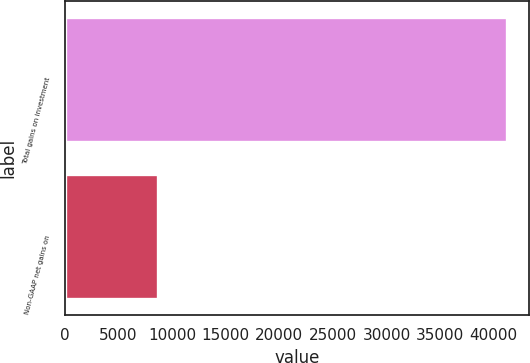Convert chart. <chart><loc_0><loc_0><loc_500><loc_500><bar_chart><fcel>Total gains on investment<fcel>Non-GAAP net gains on<nl><fcel>41198<fcel>8735.9<nl></chart> 